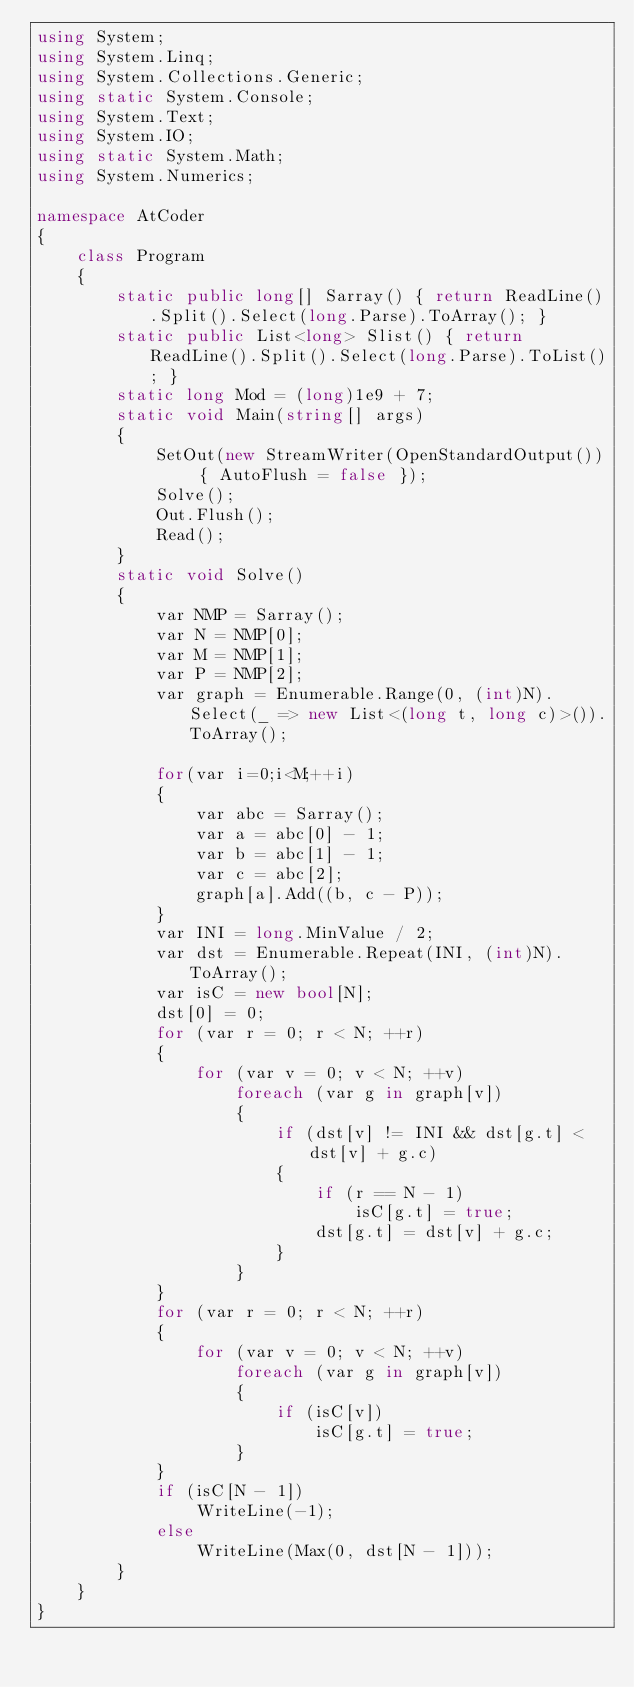Convert code to text. <code><loc_0><loc_0><loc_500><loc_500><_C#_>using System;
using System.Linq;
using System.Collections.Generic;
using static System.Console;
using System.Text;
using System.IO;
using static System.Math;
using System.Numerics;

namespace AtCoder
{
    class Program
    {
        static public long[] Sarray() { return ReadLine().Split().Select(long.Parse).ToArray(); }
        static public List<long> Slist() { return ReadLine().Split().Select(long.Parse).ToList(); }
        static long Mod = (long)1e9 + 7;
        static void Main(string[] args)
        {
            SetOut(new StreamWriter(OpenStandardOutput()) { AutoFlush = false });
            Solve();
            Out.Flush();
            Read();
        }
        static void Solve()
        {
            var NMP = Sarray();
            var N = NMP[0];
            var M = NMP[1];
            var P = NMP[2];
            var graph = Enumerable.Range(0, (int)N).Select(_ => new List<(long t, long c)>()).ToArray();

            for(var i=0;i<M;++i)
            {
                var abc = Sarray();
                var a = abc[0] - 1;
                var b = abc[1] - 1;
                var c = abc[2];
                graph[a].Add((b, c - P));
            }
            var INI = long.MinValue / 2;
            var dst = Enumerable.Repeat(INI, (int)N).ToArray();
            var isC = new bool[N];
            dst[0] = 0;
            for (var r = 0; r < N; ++r)
            {
                for (var v = 0; v < N; ++v)
                    foreach (var g in graph[v])
                    {
                        if (dst[v] != INI && dst[g.t] < dst[v] + g.c)
                        {
                            if (r == N - 1)
                                isC[g.t] = true;
                            dst[g.t] = dst[v] + g.c;
                        }
                    }
            }
            for (var r = 0; r < N; ++r)
            {
                for (var v = 0; v < N; ++v)
                    foreach (var g in graph[v])
                    {
                        if (isC[v])
                            isC[g.t] = true;
                    }
            }
            if (isC[N - 1])
                WriteLine(-1);
            else
                WriteLine(Max(0, dst[N - 1]));
        }        
    }
}</code> 